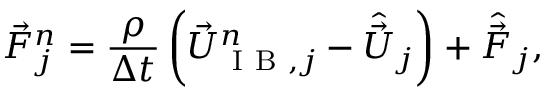<formula> <loc_0><loc_0><loc_500><loc_500>\vec { F } _ { j } ^ { n } = \frac { \rho } { \Delta t } \left ( \vec { U } _ { I B , j } ^ { n } - \hat { \vec { U } } _ { j } \right ) + \hat { \vec { F } } _ { j } ,</formula> 